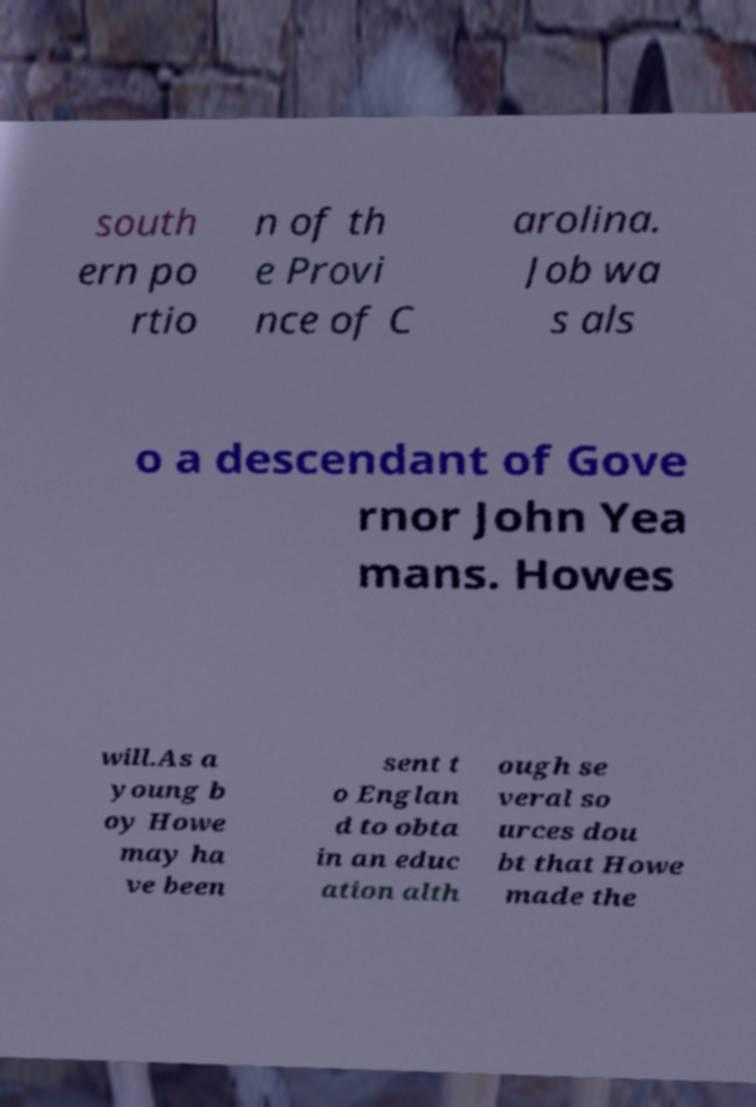Can you accurately transcribe the text from the provided image for me? south ern po rtio n of th e Provi nce of C arolina. Job wa s als o a descendant of Gove rnor John Yea mans. Howes will.As a young b oy Howe may ha ve been sent t o Englan d to obta in an educ ation alth ough se veral so urces dou bt that Howe made the 